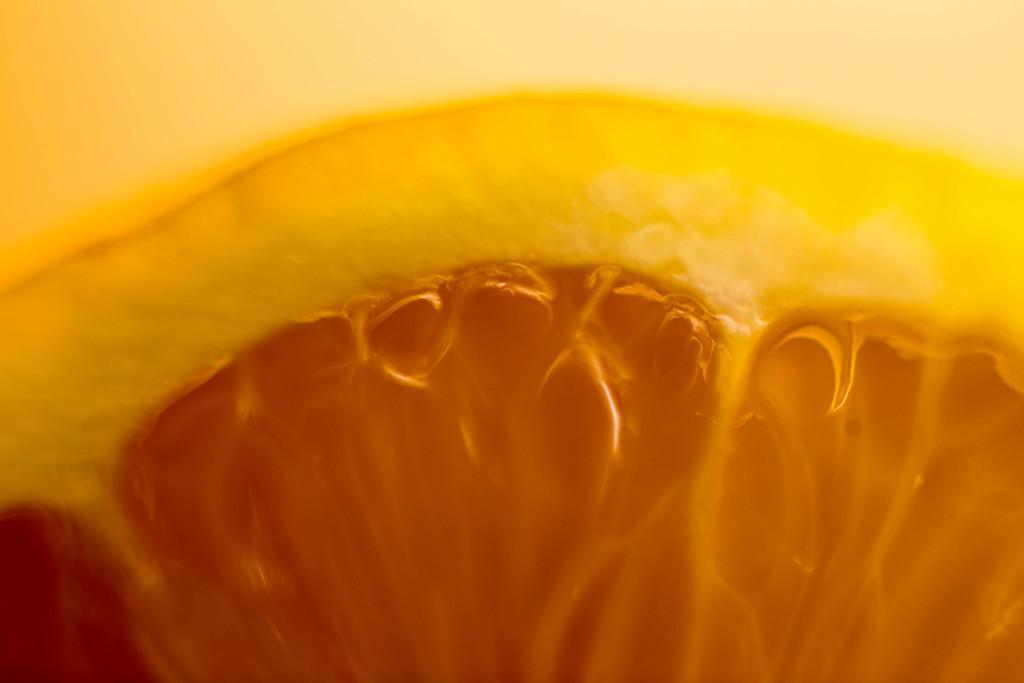In one or two sentences, can you explain what this image depicts? In this image I can see an orange and yellow colour thing. 